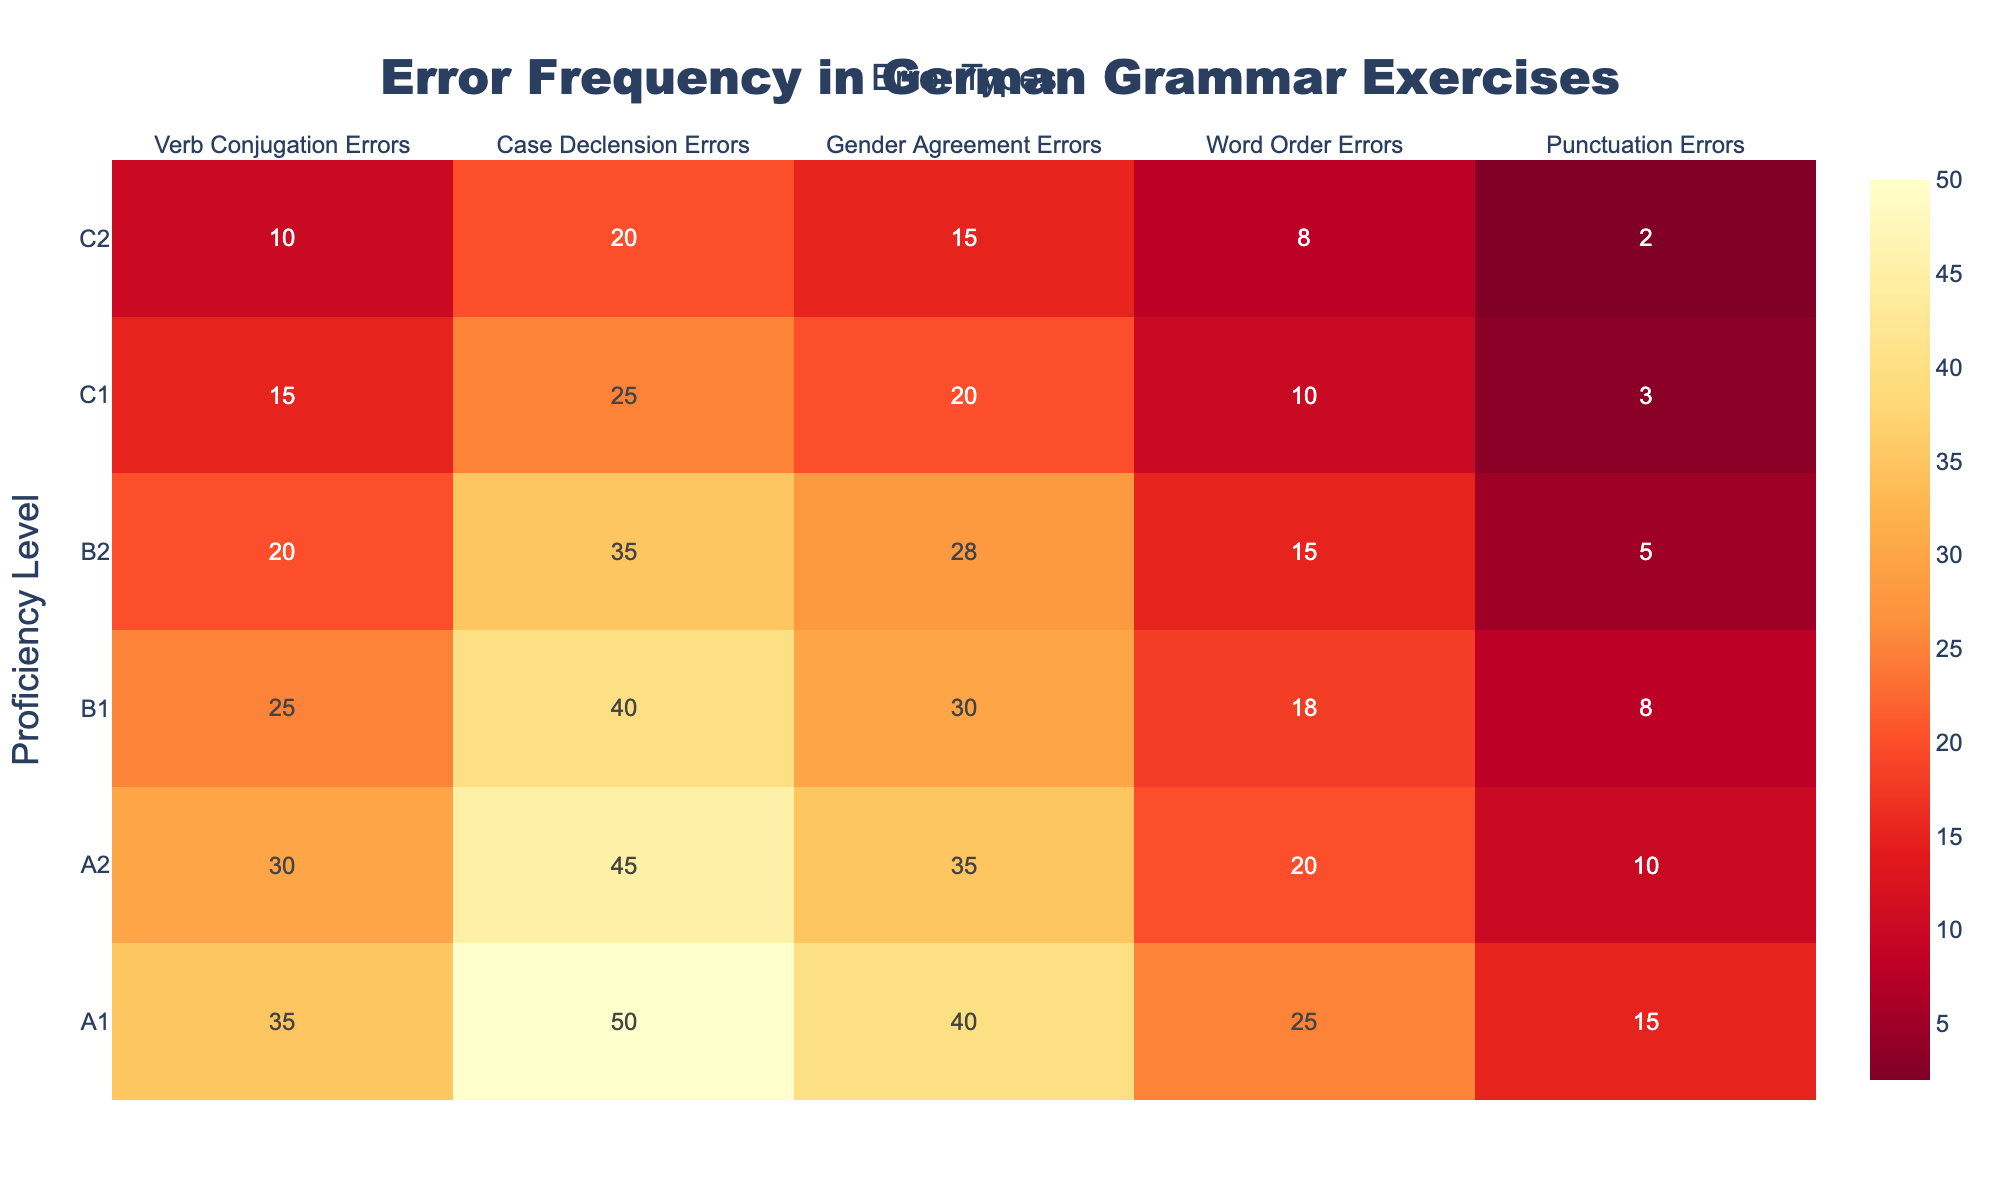What's the title of the heatmap? The title is usually placed prominently at the top of the figure. By observing the title area, you can see that it reads "Error Frequency in German Grammar Exercises".
Answer: Error Frequency in German Grammar Exercises What is the error type with the highest frequency for A1 proficiency level? To find the error type with the highest frequency for A1 proficiency level, look at the row corresponding to A1 and find the highest value. The highest value in the row is 50 under Case Declension Errors.
Answer: Case Declension Errors How does the frequency of Punctuation Errors change with increasing proficiency levels? Examine the Punctuation Errors column and observe the values from A1 to C2 proficiency levels. The values decrease as proficiency increases: 15, 10, 8, 5, 3, and 2.
Answer: Decreases Which proficiency level has the lowest total error frequency across all types? Sum the error frequencies for each proficiency level and compare. A1 (35+50+40+25+15=165), A2 (30+45+35+20+10=140), B1 (25+40+30+18+8=121), B2 (20+35+28+15+5=103), C1 (15+25+20+10+3=73), C2 (10+20+15+8+2=55). The lowest total error frequency is at the C2 level.
Answer: C2 Which proficiency level sees the most significant drop between Verb Conjugation Errors and Case Declension Errors? Calculate the difference between Verb Conjugation Errors and Case Declension Errors for each proficiency level. A1 (35-50=-15), A2 (30-45=-15), B1 (25-40=-15), B2 (20-35=-15), C1 (15-25=-10), C2 (10-20=-10). The most significant drops are found at the A1, A2, B1, and B2 levels with a difference of -15 each.
Answer: A1, A2, B1, B2 Compare the frequency of Gender Agreement Errors at the B2 and C1 levels. Which is higher? Look at the row corresponding to B2 and C1 and compare the values under the Gender Agreement Errors column. B2 has 28 and C1 has 20.
Answer: B2 What is the average number of Word Order Errors from A1 to C2 levels? Sum the number of Word Order Errors across all proficiency levels and divide by the number of levels: (25+20+18+15+10+8)/6 = 96/6 = 16.
Answer: 16 Which error type shows the least improvement from A1 to C2 levels? Improvement can be measured by the decrease in error frequency. Calculate the differences for each error type from A1 to C2. Verb Conjugation Errors (35-10=25), Case Declension Errors (50-20=30), Gender Agreement Errors (40-15=25), Word Order Errors (25-8=17), Punctuation Errors (15-2=13). The least improvement is in Punctuation Errors, with a decrease of 13.
Answer: Punctuation Errors How does the trend of Case Declension Errors compare to Word Order Errors from A1 to C2? Observe the columns for Case Declension Errors and Word Order Errors across proficiency levels. Both trends show a decrease in errors as proficiency increases. However, the decrease is steeper for Case Declension Errors (50 to 20) compared to Word Order Errors (25 to 8).
Answer: Case Declension Errors decrease more steeply 